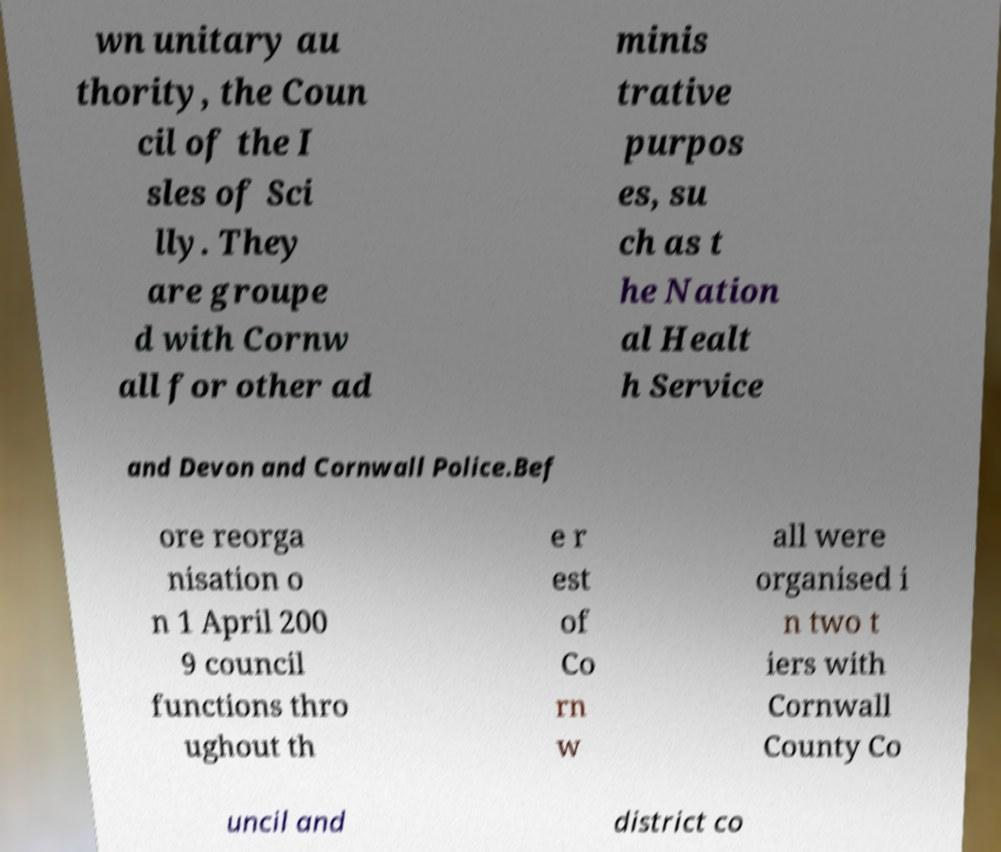Can you read and provide the text displayed in the image?This photo seems to have some interesting text. Can you extract and type it out for me? wn unitary au thority, the Coun cil of the I sles of Sci lly. They are groupe d with Cornw all for other ad minis trative purpos es, su ch as t he Nation al Healt h Service and Devon and Cornwall Police.Bef ore reorga nisation o n 1 April 200 9 council functions thro ughout th e r est of Co rn w all were organised i n two t iers with Cornwall County Co uncil and district co 